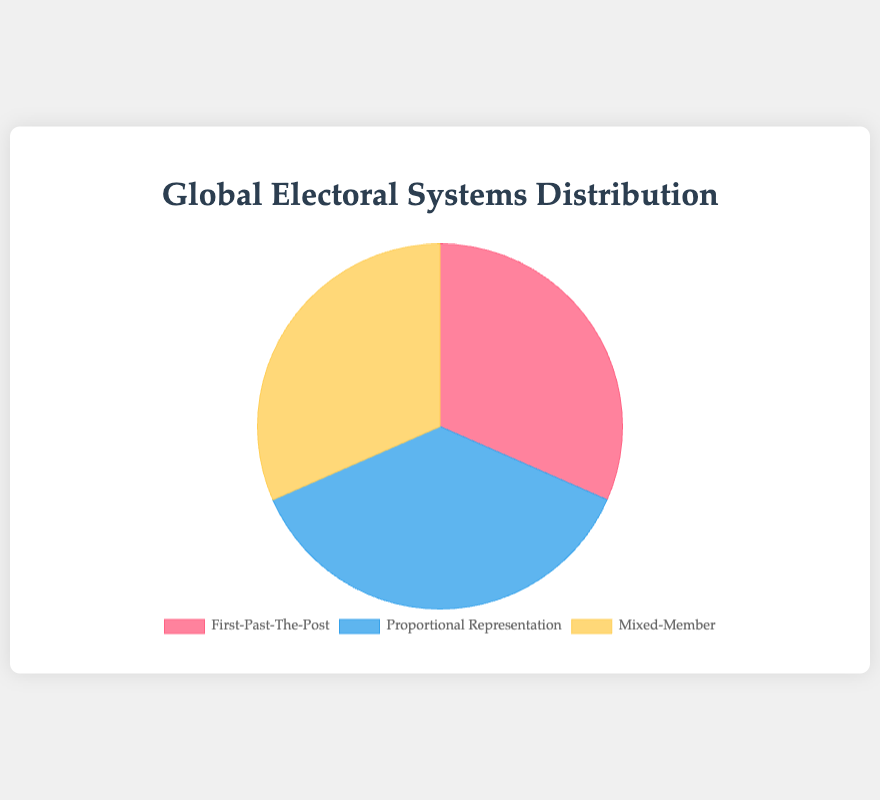What percentage of the countries use the First-Past-The-Post system? The slice for the First-Past-The-Post system is labeled with its data percentage. The total number of countries is 19, and the number of First-Past-The-Post countries is 6. Calculate \( (6 / 19) \times 100 \) to get the percentage, which is approximately 31.6%.
Answer: 31.6% How many more countries use Proportional Representation compared to Mixed-Member? The pie chart shows that the number of Proportional Representation countries is 7 and Mixed-Member countries is 6. Subtract the number of Mixed-Member countries from Proportional Representation: \( 7 - 6 \). This equals 1.
Answer: 1 Which electoral system is the least common among the given data? The pie chart segments are labeled, and you can observe that the Mixed-Member system has the smallest slice, implying it is the least common. There are 6 countries using the Mixed-Member system out of the 19 total countries.
Answer: Mixed-Member What proportion of countries use Mixed-Member systems? From the chart, there are 6 Mixed-Member system countries out of a total of 19 countries. Calculate the proportion \( 6 / 19 \), which is approximately 0.316, or 31.6%.
Answer: 31.6% If two additional countries adopted the Proportional Representation system, what would be the new percentage for this category? Currently, there are 7 countries using Proportional Representation out of 19. If 2 more countries adopted it, there would be 9 out of 21 countries. Calculate \( (9 / 21) \times 100 \) to get the new percentage: approximately 42.9%.
Answer: 42.9% What is the ratio of countries using First-Past-The-Post to those using Proportional Representation? The pie chart displays 6 countries using First-Past-The-Post and 7 using Proportional Representation. The ratio is \( 6:7 \).
Answer: 6:7 Which color represents the Proportional Representation system in the pie chart? The Proportional Representation segment is labeled, and observing the color of this segment in the visual part of the chart, it’s shaded blue.
Answer: Blue How many total countries are represented in the chart? Sum the number of countries from each electoral system segment: 6 (First-Past-The-Post) + 7 (Proportional Representation) + 6 (Mixed-Member). The total is 19.
Answer: 19 